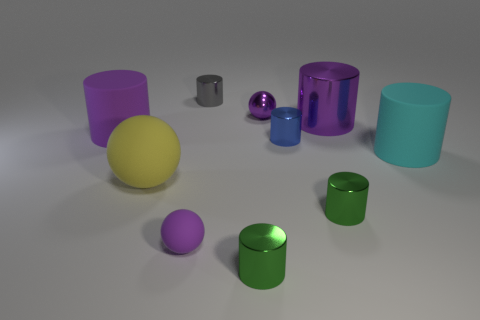Subtract all big spheres. How many spheres are left? 2 Subtract all gray cylinders. How many cylinders are left? 6 Subtract all red cylinders. How many purple spheres are left? 2 Subtract 2 spheres. How many spheres are left? 1 Subtract all spheres. How many objects are left? 7 Subtract all yellow cylinders. Subtract all cyan spheres. How many cylinders are left? 7 Subtract all purple shiny spheres. Subtract all big rubber cylinders. How many objects are left? 7 Add 5 rubber balls. How many rubber balls are left? 7 Add 9 small brown matte balls. How many small brown matte balls exist? 9 Subtract 0 gray cubes. How many objects are left? 10 